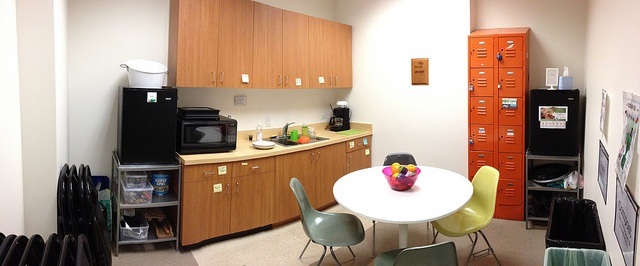Describe the objects in this image and their specific colors. I can see dining table in white, brown, tan, and darkgray tones, chair in white, olive, and khaki tones, chair in white, gray, darkgray, and black tones, chair in white, black, and gray tones, and microwave in white, black, and gray tones in this image. 